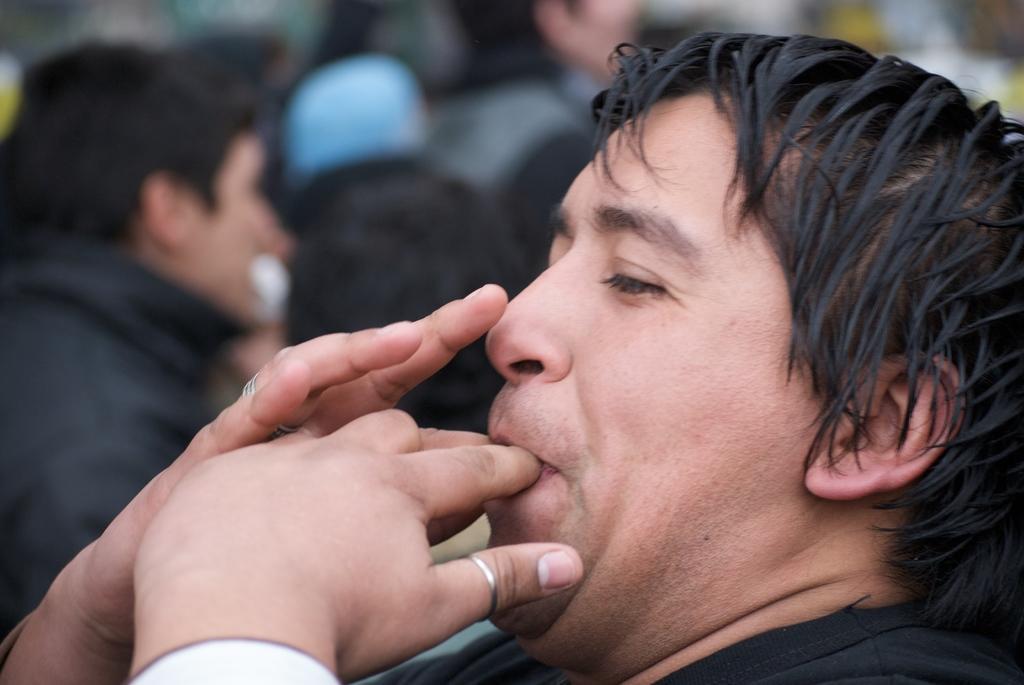Can you describe this image briefly? In this in the foreground there is a person kept his fingers on his mouth and in the background there might be crowd. 